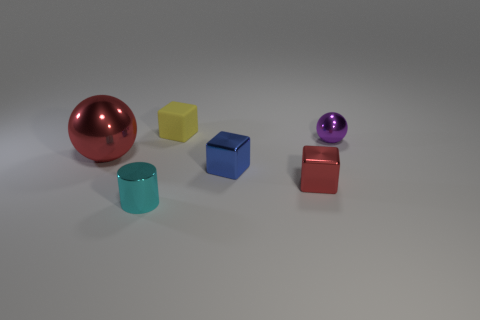There is a metallic object that is left of the small cylinder; what is its shape?
Ensure brevity in your answer.  Sphere. There is a red object that is on the right side of the red thing to the left of the tiny yellow object; what is its material?
Your answer should be compact. Metal. Is the number of red things in front of the tiny cyan cylinder greater than the number of cyan cylinders?
Offer a terse response. No. What number of other objects are there of the same color as the metallic cylinder?
Your response must be concise. 0. What is the shape of the blue metal object that is the same size as the cyan cylinder?
Keep it short and to the point. Cube. How many tiny spheres are behind the metallic sphere that is right of the cyan object left of the tiny shiny sphere?
Give a very brief answer. 0. How many metallic things are either yellow cubes or small purple things?
Your answer should be compact. 1. What color is the shiny object that is both behind the tiny blue shiny cube and on the left side of the small red cube?
Provide a short and direct response. Red. Does the red metal object that is left of the cyan thing have the same size as the small metal cylinder?
Provide a short and direct response. No. What number of objects are either small metallic objects that are to the left of the small rubber block or cyan rubber balls?
Provide a short and direct response. 1. 